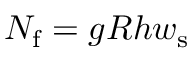Convert formula to latex. <formula><loc_0><loc_0><loc_500><loc_500>N _ { f } = g R h w _ { s }</formula> 